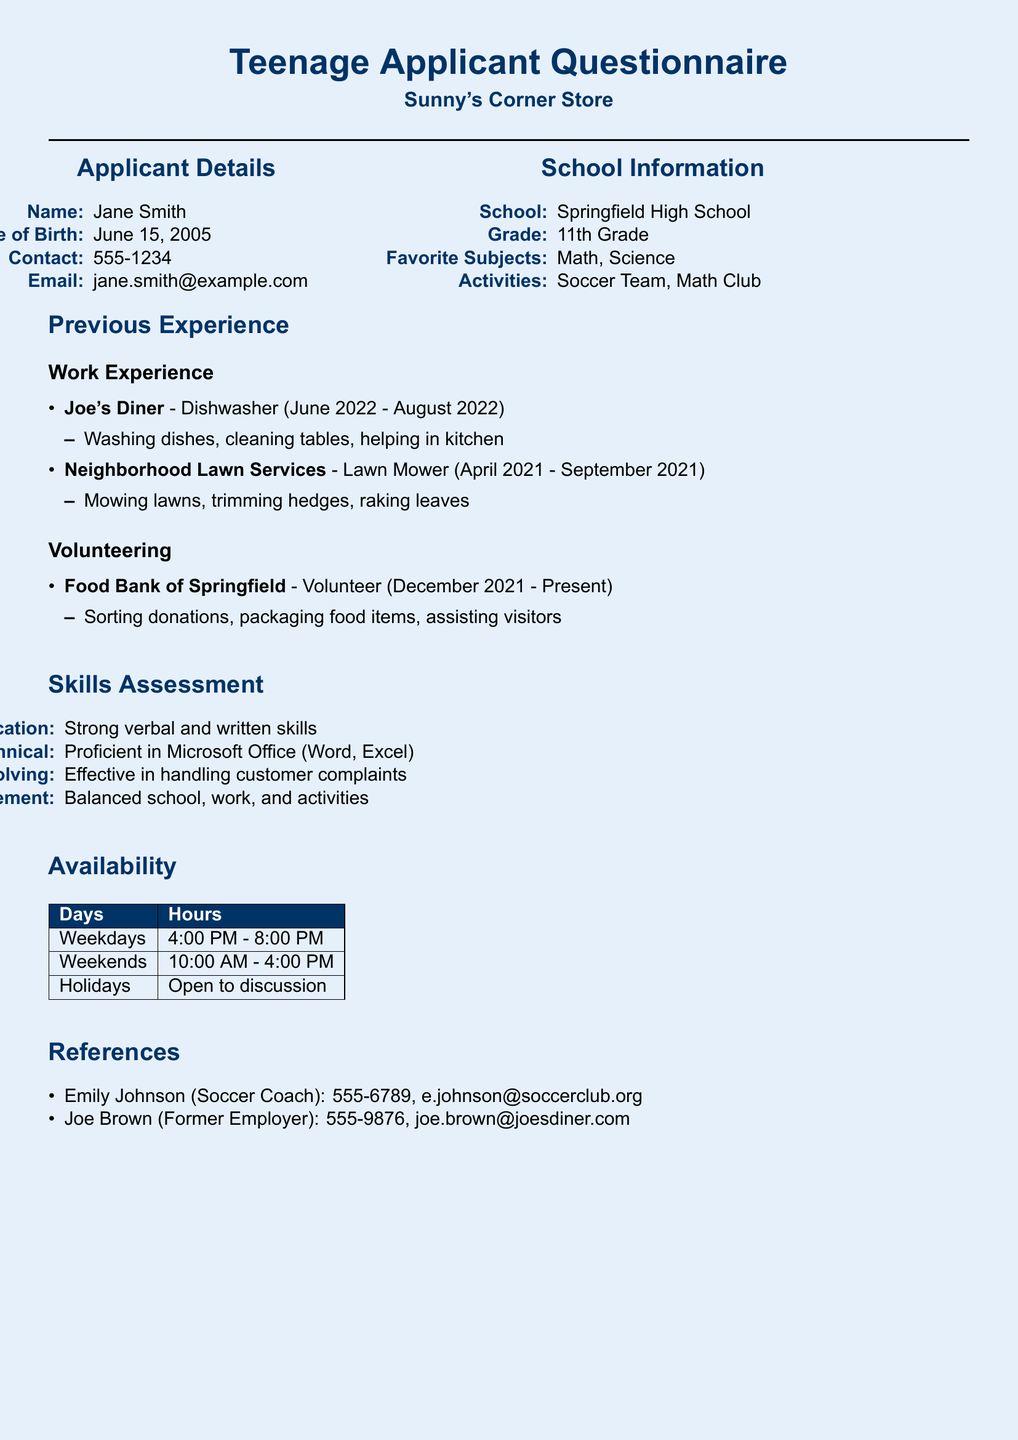What is the applicant's name? The applicant's name is provided in the "Applicant Details" section of the document.
Answer: Jane Smith What school does the applicant attend? The school information is listed under the "School Information" section.
Answer: Springfield High School What was the applicant's job title at Joe's Diner? The job title is mentioned in the "Work Experience" section relating to the applicant's experience.
Answer: Dishwasher What is the applicant's favorite subject? The favorite subjects are specified in the "School Information" section of the document.
Answer: Math, Science How many years of experience does the applicant have as a volunteer? The volunteering experience spans from December 2021 to the present as noted in the document.
Answer: Nearly 2 years What skill does the applicant describe themselves as having in problem-solving? The applicant's competence in problem-solving is outlined in the "Skills Assessment" section.
Answer: Effective in handling customer complaints What days is the applicant available to work? The days available for work are listed in the "Availability" section of the document.
Answer: Weekdays, Weekends How can the applicant be contacted? The contact information for the applicant is provided in the "Applicant Details" section.
Answer: 555-1234 What is the applicant's availability on holidays? The holiday availability is discussed in the "Availability" section and specifies the applicant's flexibility.
Answer: Open to discussion 